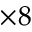<formula> <loc_0><loc_0><loc_500><loc_500>\times 8</formula> 